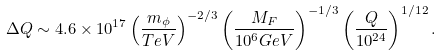<formula> <loc_0><loc_0><loc_500><loc_500>\Delta Q \sim 4 . 6 \times 1 0 ^ { 1 7 } \left ( \frac { m _ { \phi } } { T e V } \right ) ^ { - 2 / 3 } \left ( \frac { M _ { F } } { 1 0 ^ { 6 } G e V } \right ) ^ { - 1 / 3 } \left ( \frac { Q } { 1 0 ^ { 2 4 } } \right ) ^ { 1 / 1 2 } .</formula> 